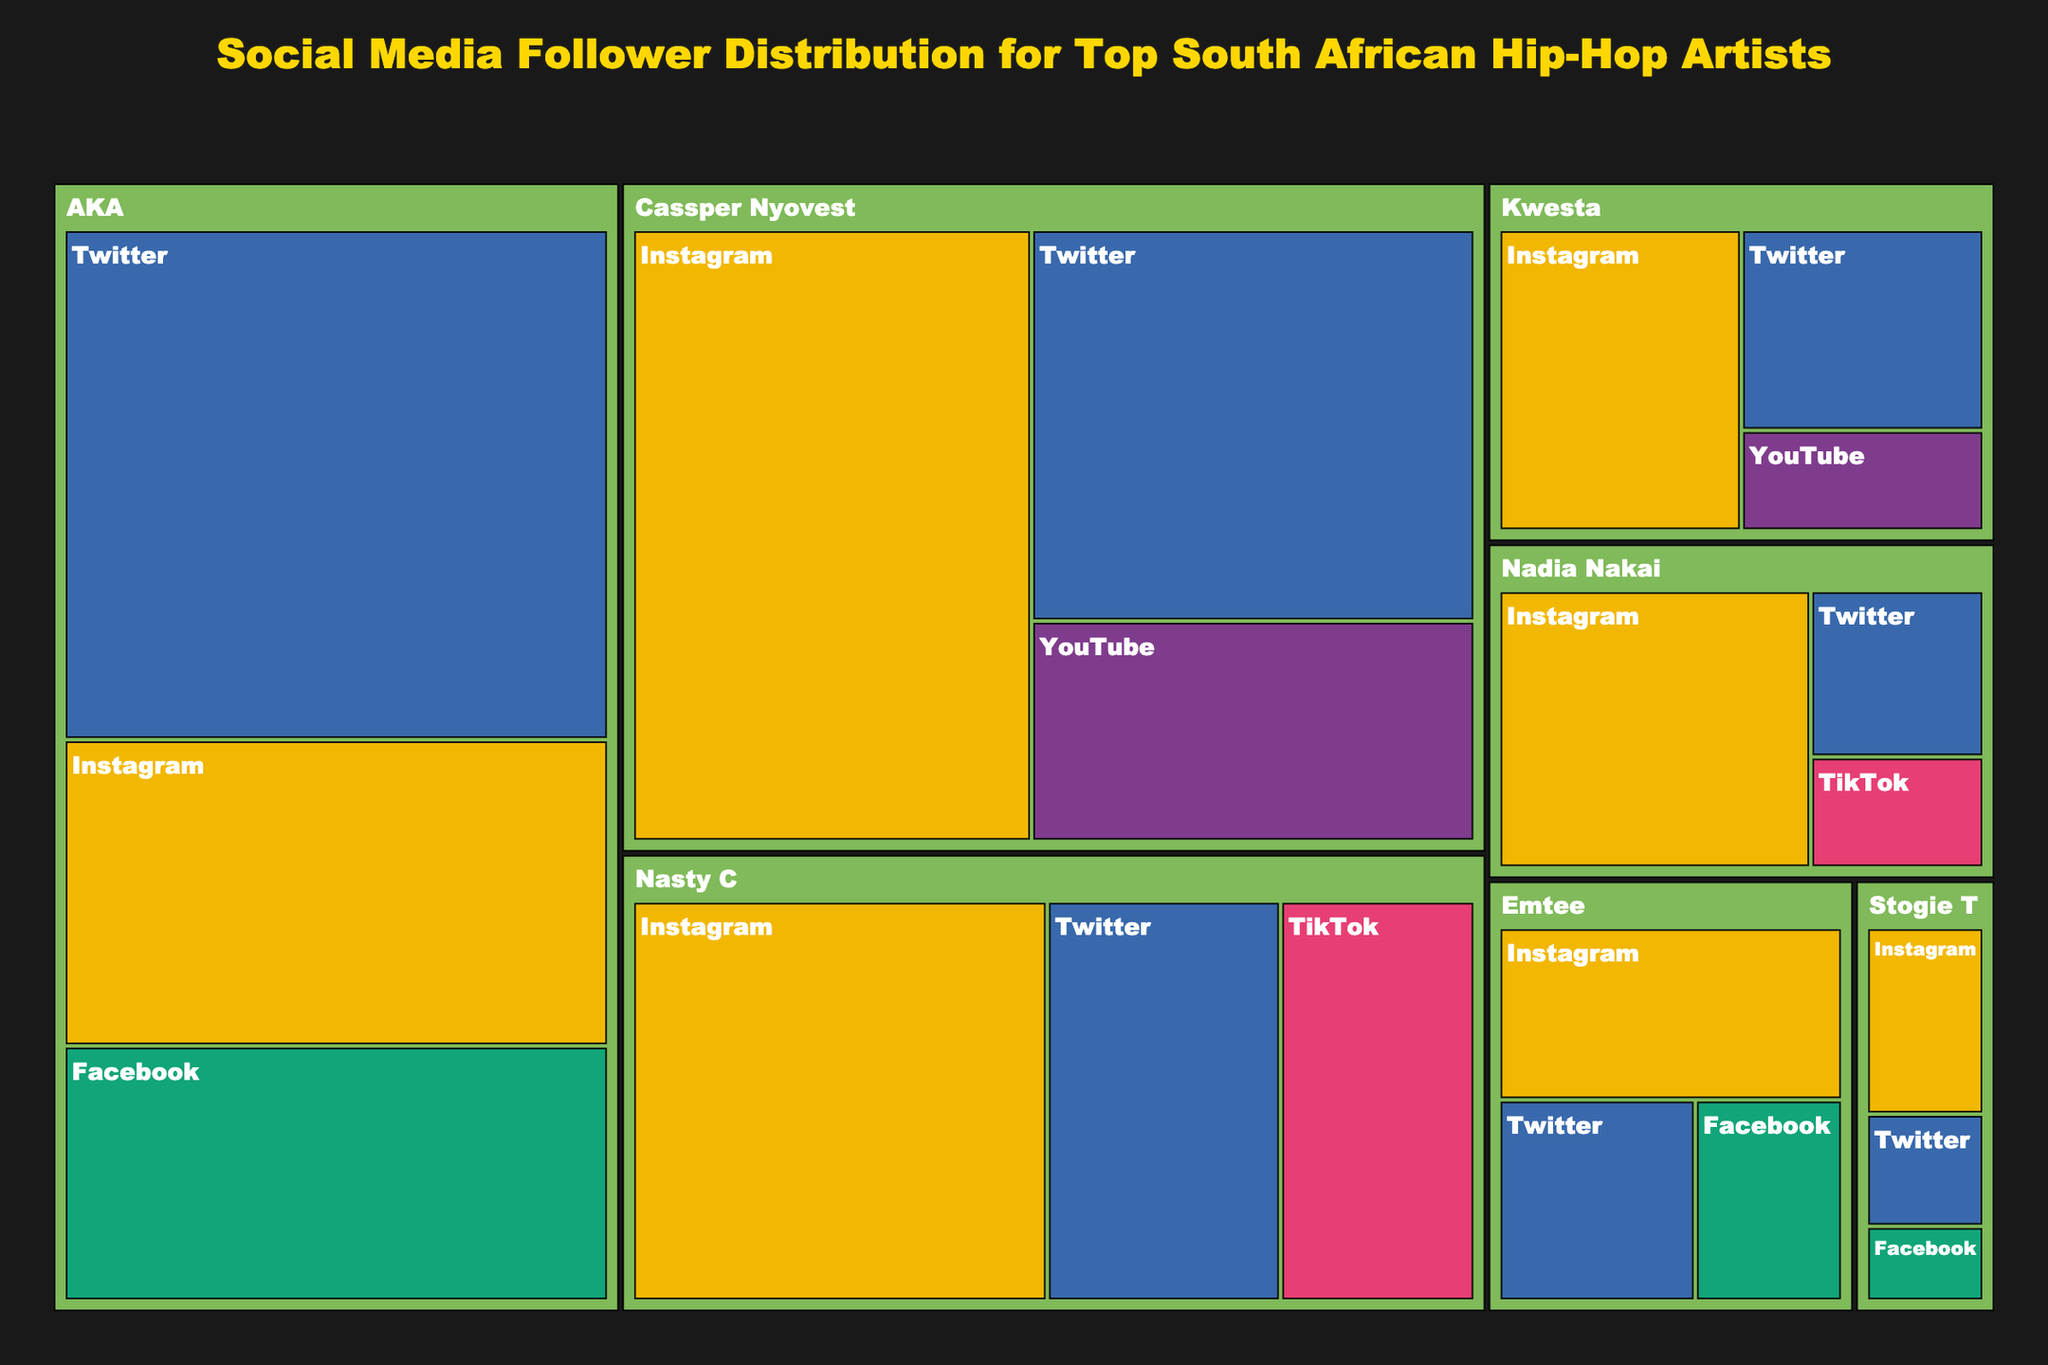What is the title of the figure? The title is displayed prominently at the top of the Treemap and gives an indication of what the figure represents.
Answer: Social Media Follower Distribution for Top South African Hip-Hop Artists Which artist has the highest total number of followers across all platforms? By observing the relative size of the artist blocks in the Treemap, we can identify the artist with the largest area.
Answer: Cassper Nyovest How many social media platforms are represented in the figure? The platforms are indicated by different colors in the Treemap. Count the distinct colors to determine the number.
Answer: 5 Which platform has the most significant share for Nasty C? Looking at the size of the sub-blocks under Nasty C's section in the Treemap, determine which platform has the largest block.
Answer: Instagram Who has more followers on Twitter, AKA or Cassper Nyovest? Compare the sizes of the Twitter blocks under both AKA and Cassper Nyovest in the Treemap.
Answer: AKA What is the sum of followers on Instagram for all artists combined? Identify all Instagram blocks in the Treemap and add their respective follower counts.
Answer: 13,950,000 Among the artists shown, whose Facebook following is the least? Inspect the Facebook blocks in the Treemap and find the one with the smallest area.
Answer: Stogie T Which artist has a presence on the fewest number of platforms? Compare the number of different colored blocks under each artist in the Treemap to identify who is on the fewest platforms.
Answer: Stogie T Which artist has the smallest total number of followers? Identify the artist block with the smallest area in the Treemap.
Answer: Stogie T How does Kwesta's total follower count compare to Nadia Nakai's? Determine the relative area of Kwesta's block versus Nadia Nakai's block to compare their total follower counts.
Answer: Kwesta has more followers than Nadia Nakai 